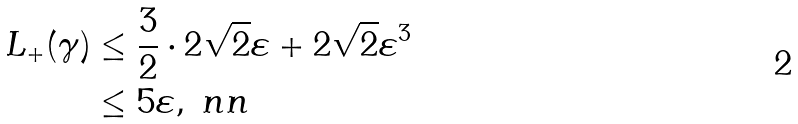<formula> <loc_0><loc_0><loc_500><loc_500>L _ { + } ( \gamma ) & \leq \frac { 3 } { 2 } \cdot 2 \sqrt { 2 } \varepsilon + 2 \sqrt { 2 } \varepsilon ^ { 3 } \\ & \leq 5 \varepsilon , \ n n</formula> 